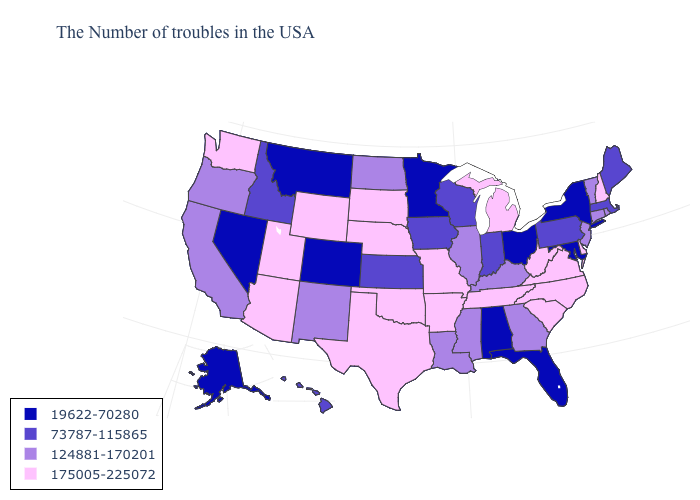Does New Jersey have a lower value than Delaware?
Keep it brief. Yes. What is the value of Texas?
Be succinct. 175005-225072. Does Massachusetts have a higher value than Missouri?
Concise answer only. No. Among the states that border Illinois , does Wisconsin have the highest value?
Answer briefly. No. Which states have the highest value in the USA?
Give a very brief answer. New Hampshire, Delaware, Virginia, North Carolina, South Carolina, West Virginia, Michigan, Tennessee, Missouri, Arkansas, Nebraska, Oklahoma, Texas, South Dakota, Wyoming, Utah, Arizona, Washington. Among the states that border Oregon , does Nevada have the lowest value?
Quick response, please. Yes. Does Washington have the lowest value in the USA?
Write a very short answer. No. What is the highest value in the South ?
Be succinct. 175005-225072. Among the states that border Massachusetts , which have the highest value?
Write a very short answer. New Hampshire. Among the states that border Iowa , does Missouri have the highest value?
Be succinct. Yes. Does the map have missing data?
Keep it brief. No. Name the states that have a value in the range 124881-170201?
Concise answer only. Rhode Island, Vermont, Connecticut, New Jersey, Georgia, Kentucky, Illinois, Mississippi, Louisiana, North Dakota, New Mexico, California, Oregon. Name the states that have a value in the range 73787-115865?
Quick response, please. Maine, Massachusetts, Pennsylvania, Indiana, Wisconsin, Iowa, Kansas, Idaho, Hawaii. What is the highest value in the South ?
Give a very brief answer. 175005-225072. What is the value of New Hampshire?
Concise answer only. 175005-225072. 